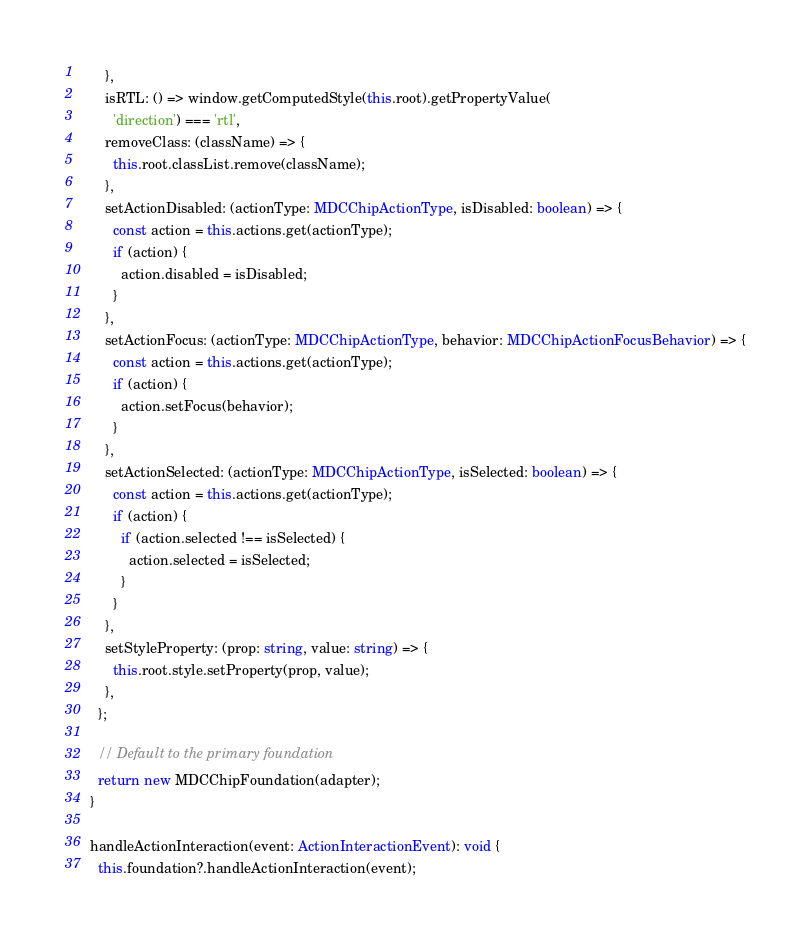<code> <loc_0><loc_0><loc_500><loc_500><_TypeScript_>      },
      isRTL: () => window.getComputedStyle(this.root).getPropertyValue(
        'direction') === 'rtl',
      removeClass: (className) => {
        this.root.classList.remove(className);
      },
      setActionDisabled: (actionType: MDCChipActionType, isDisabled: boolean) => {
        const action = this.actions.get(actionType);
        if (action) {
          action.disabled = isDisabled;
        }
      },
      setActionFocus: (actionType: MDCChipActionType, behavior: MDCChipActionFocusBehavior) => {
        const action = this.actions.get(actionType);
        if (action) {
          action.setFocus(behavior);
        }
      },
      setActionSelected: (actionType: MDCChipActionType, isSelected: boolean) => {
        const action = this.actions.get(actionType);
        if (action) {
          if (action.selected !== isSelected) {
            action.selected = isSelected;
          }
        }
      },
      setStyleProperty: (prop: string, value: string) => {
        this.root.style.setProperty(prop, value);
      },
    };

    // Default to the primary foundation
    return new MDCChipFoundation(adapter);
  }

  handleActionInteraction(event: ActionInteractionEvent): void {
    this.foundation?.handleActionInteraction(event);</code> 